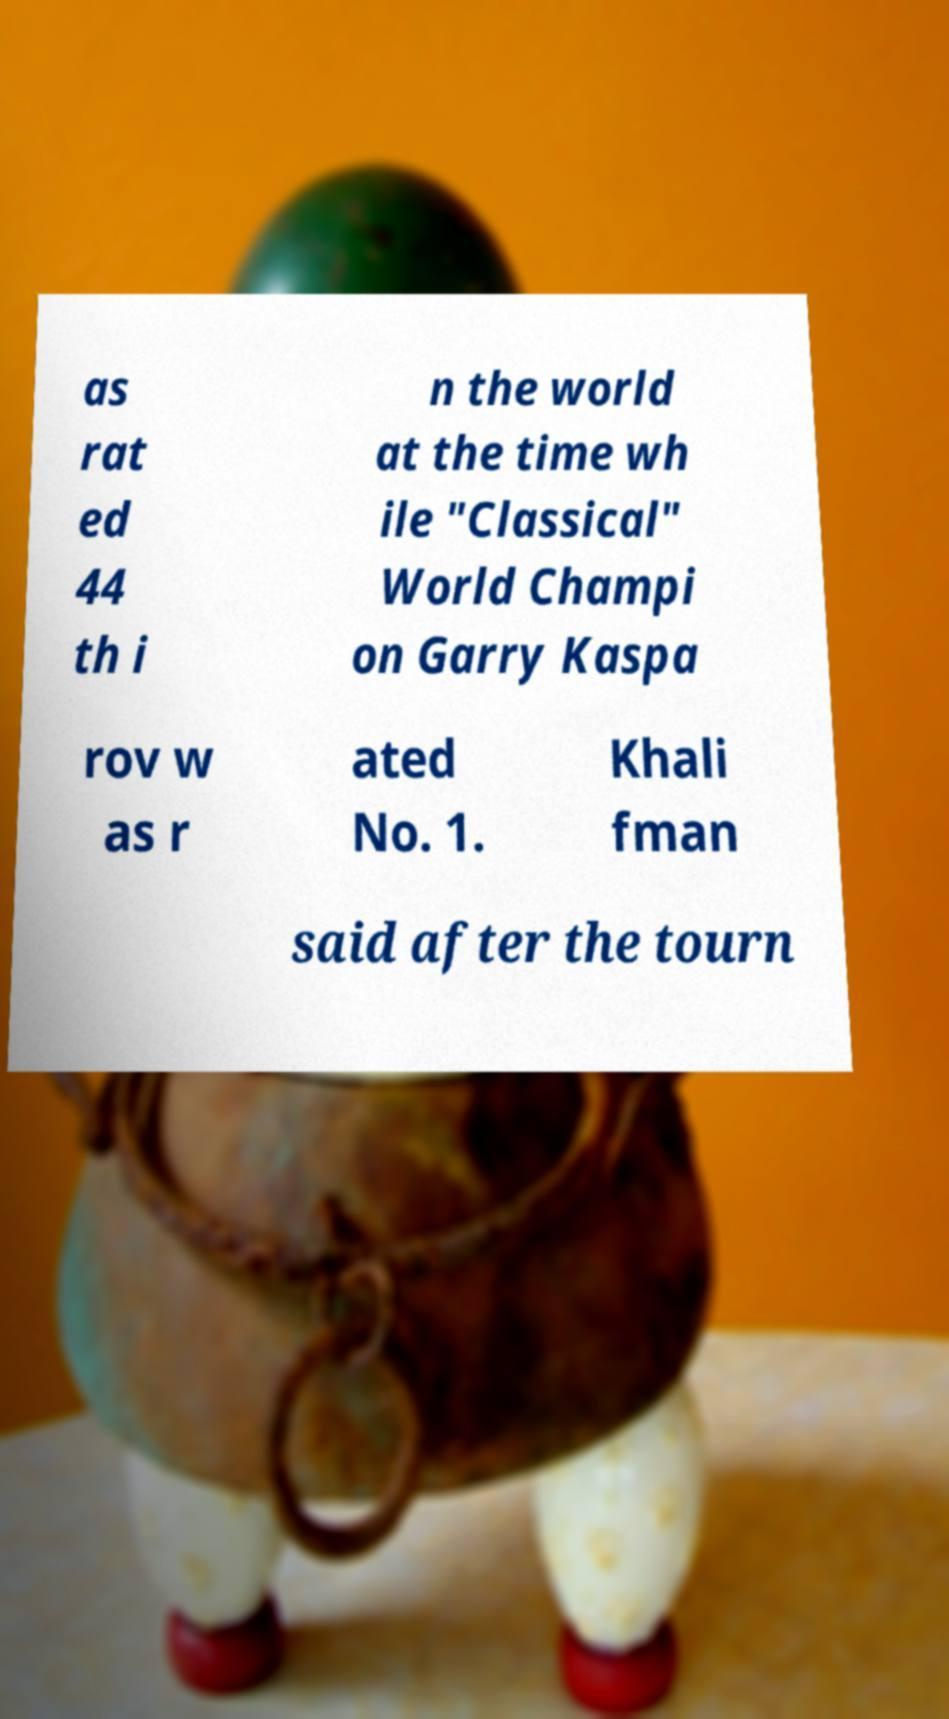Could you extract and type out the text from this image? as rat ed 44 th i n the world at the time wh ile "Classical" World Champi on Garry Kaspa rov w as r ated No. 1. Khali fman said after the tourn 